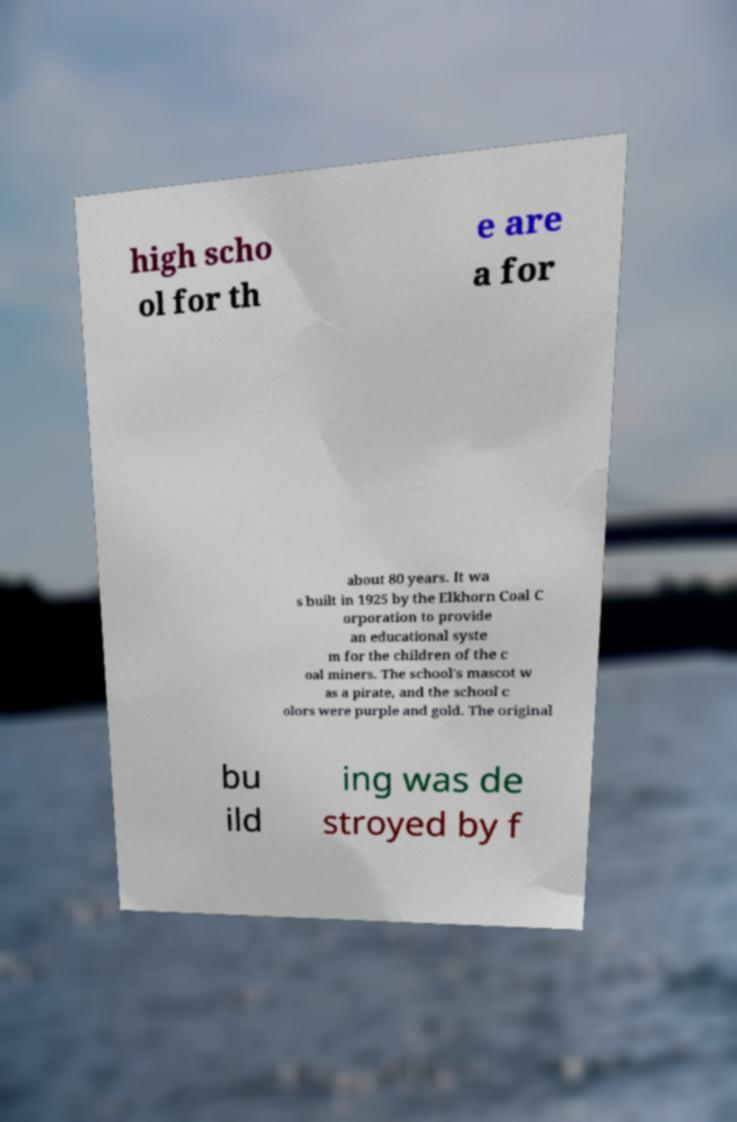Can you read and provide the text displayed in the image?This photo seems to have some interesting text. Can you extract and type it out for me? high scho ol for th e are a for about 80 years. It wa s built in 1925 by the Elkhorn Coal C orporation to provide an educational syste m for the children of the c oal miners. The school's mascot w as a pirate, and the school c olors were purple and gold. The original bu ild ing was de stroyed by f 